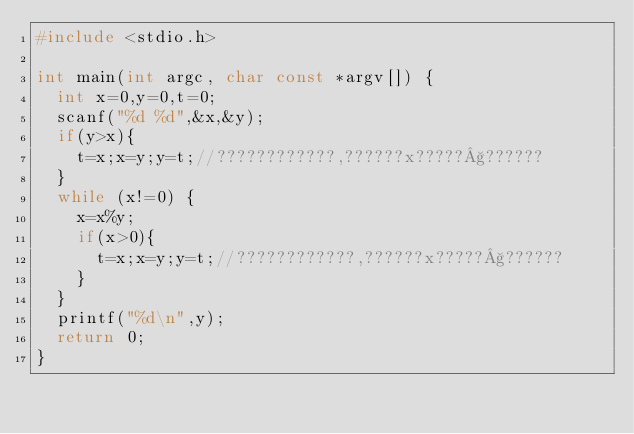Convert code to text. <code><loc_0><loc_0><loc_500><loc_500><_C_>#include <stdio.h>

int main(int argc, char const *argv[]) {
  int x=0,y=0,t=0;
  scanf("%d %d",&x,&y);
  if(y>x){
    t=x;x=y;y=t;//????????????,??????x?????§??????
  }
  while (x!=0) {
    x=x%y;
    if(x>0){
      t=x;x=y;y=t;//????????????,??????x?????§??????
    }
  }
  printf("%d\n",y);
  return 0;
}</code> 